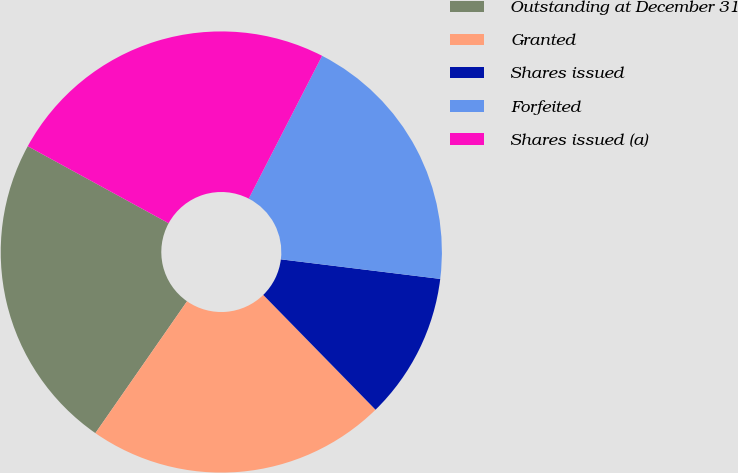Convert chart. <chart><loc_0><loc_0><loc_500><loc_500><pie_chart><fcel>Outstanding at December 31<fcel>Granted<fcel>Shares issued<fcel>Forfeited<fcel>Shares issued (a)<nl><fcel>23.29%<fcel>21.99%<fcel>10.73%<fcel>19.39%<fcel>24.59%<nl></chart> 